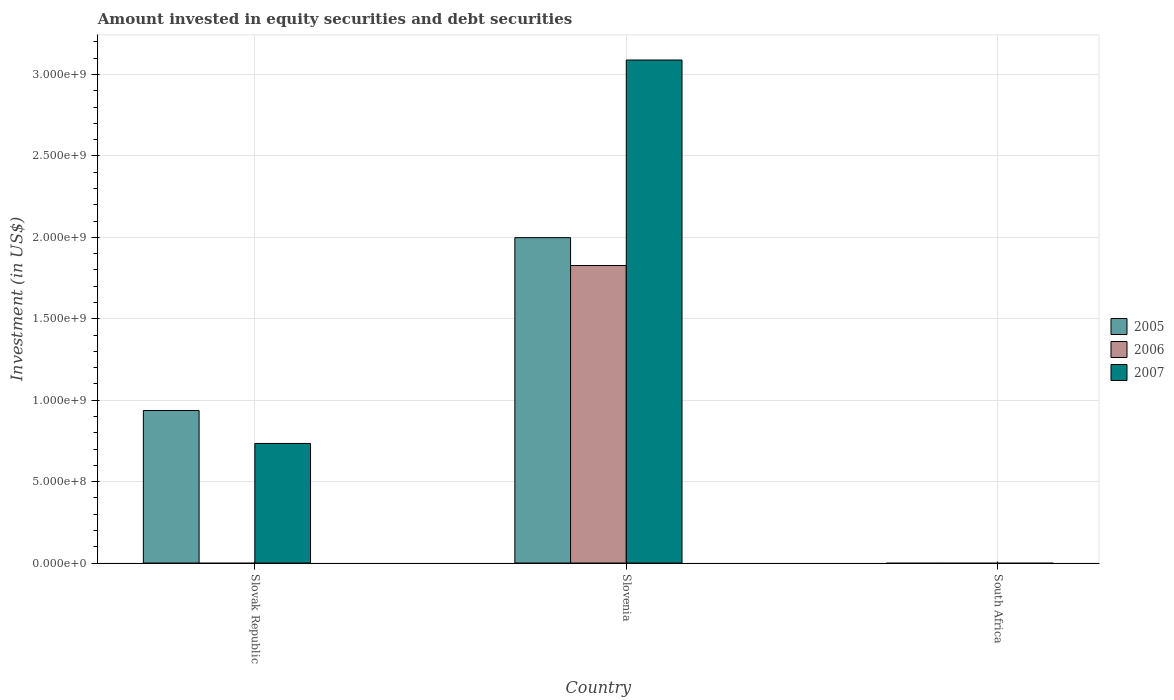Are the number of bars per tick equal to the number of legend labels?
Make the answer very short. No. Are the number of bars on each tick of the X-axis equal?
Your answer should be compact. No. How many bars are there on the 1st tick from the right?
Keep it short and to the point. 0. What is the label of the 3rd group of bars from the left?
Provide a short and direct response. South Africa. What is the amount invested in equity securities and debt securities in 2006 in Slovak Republic?
Your response must be concise. 0. Across all countries, what is the maximum amount invested in equity securities and debt securities in 2006?
Ensure brevity in your answer.  1.83e+09. In which country was the amount invested in equity securities and debt securities in 2007 maximum?
Ensure brevity in your answer.  Slovenia. What is the total amount invested in equity securities and debt securities in 2007 in the graph?
Offer a terse response. 3.82e+09. What is the difference between the amount invested in equity securities and debt securities in 2007 in Slovak Republic and that in Slovenia?
Ensure brevity in your answer.  -2.35e+09. What is the difference between the amount invested in equity securities and debt securities in 2005 in Slovak Republic and the amount invested in equity securities and debt securities in 2007 in Slovenia?
Your answer should be compact. -2.15e+09. What is the average amount invested in equity securities and debt securities in 2006 per country?
Ensure brevity in your answer.  6.09e+08. What is the difference between the amount invested in equity securities and debt securities of/in 2007 and amount invested in equity securities and debt securities of/in 2006 in Slovenia?
Offer a very short reply. 1.26e+09. What is the ratio of the amount invested in equity securities and debt securities in 2007 in Slovak Republic to that in Slovenia?
Offer a terse response. 0.24. Is the amount invested in equity securities and debt securities in 2007 in Slovak Republic less than that in Slovenia?
Give a very brief answer. Yes. What is the difference between the highest and the lowest amount invested in equity securities and debt securities in 2005?
Keep it short and to the point. 2.00e+09. In how many countries, is the amount invested in equity securities and debt securities in 2005 greater than the average amount invested in equity securities and debt securities in 2005 taken over all countries?
Offer a very short reply. 1. Is the sum of the amount invested in equity securities and debt securities in 2007 in Slovak Republic and Slovenia greater than the maximum amount invested in equity securities and debt securities in 2006 across all countries?
Provide a short and direct response. Yes. How many bars are there?
Ensure brevity in your answer.  5. Are all the bars in the graph horizontal?
Provide a succinct answer. No. How many countries are there in the graph?
Keep it short and to the point. 3. Are the values on the major ticks of Y-axis written in scientific E-notation?
Provide a short and direct response. Yes. Does the graph contain any zero values?
Offer a very short reply. Yes. Does the graph contain grids?
Keep it short and to the point. Yes. What is the title of the graph?
Offer a very short reply. Amount invested in equity securities and debt securities. What is the label or title of the X-axis?
Your answer should be compact. Country. What is the label or title of the Y-axis?
Provide a succinct answer. Investment (in US$). What is the Investment (in US$) of 2005 in Slovak Republic?
Your response must be concise. 9.37e+08. What is the Investment (in US$) of 2007 in Slovak Republic?
Make the answer very short. 7.34e+08. What is the Investment (in US$) of 2005 in Slovenia?
Ensure brevity in your answer.  2.00e+09. What is the Investment (in US$) of 2006 in Slovenia?
Provide a succinct answer. 1.83e+09. What is the Investment (in US$) in 2007 in Slovenia?
Provide a short and direct response. 3.09e+09. What is the Investment (in US$) in 2005 in South Africa?
Your answer should be compact. 0. What is the Investment (in US$) in 2007 in South Africa?
Your answer should be compact. 0. Across all countries, what is the maximum Investment (in US$) in 2005?
Offer a terse response. 2.00e+09. Across all countries, what is the maximum Investment (in US$) of 2006?
Your response must be concise. 1.83e+09. Across all countries, what is the maximum Investment (in US$) of 2007?
Keep it short and to the point. 3.09e+09. Across all countries, what is the minimum Investment (in US$) of 2005?
Your response must be concise. 0. Across all countries, what is the minimum Investment (in US$) in 2006?
Your response must be concise. 0. Across all countries, what is the minimum Investment (in US$) in 2007?
Your answer should be compact. 0. What is the total Investment (in US$) of 2005 in the graph?
Offer a terse response. 2.93e+09. What is the total Investment (in US$) in 2006 in the graph?
Your answer should be compact. 1.83e+09. What is the total Investment (in US$) of 2007 in the graph?
Provide a succinct answer. 3.82e+09. What is the difference between the Investment (in US$) of 2005 in Slovak Republic and that in Slovenia?
Provide a short and direct response. -1.06e+09. What is the difference between the Investment (in US$) of 2007 in Slovak Republic and that in Slovenia?
Keep it short and to the point. -2.35e+09. What is the difference between the Investment (in US$) in 2005 in Slovak Republic and the Investment (in US$) in 2006 in Slovenia?
Provide a short and direct response. -8.90e+08. What is the difference between the Investment (in US$) of 2005 in Slovak Republic and the Investment (in US$) of 2007 in Slovenia?
Offer a terse response. -2.15e+09. What is the average Investment (in US$) of 2005 per country?
Provide a succinct answer. 9.78e+08. What is the average Investment (in US$) of 2006 per country?
Offer a very short reply. 6.09e+08. What is the average Investment (in US$) of 2007 per country?
Make the answer very short. 1.27e+09. What is the difference between the Investment (in US$) of 2005 and Investment (in US$) of 2007 in Slovak Republic?
Offer a very short reply. 2.02e+08. What is the difference between the Investment (in US$) of 2005 and Investment (in US$) of 2006 in Slovenia?
Offer a terse response. 1.71e+08. What is the difference between the Investment (in US$) in 2005 and Investment (in US$) in 2007 in Slovenia?
Ensure brevity in your answer.  -1.09e+09. What is the difference between the Investment (in US$) of 2006 and Investment (in US$) of 2007 in Slovenia?
Give a very brief answer. -1.26e+09. What is the ratio of the Investment (in US$) in 2005 in Slovak Republic to that in Slovenia?
Provide a short and direct response. 0.47. What is the ratio of the Investment (in US$) in 2007 in Slovak Republic to that in Slovenia?
Provide a succinct answer. 0.24. What is the difference between the highest and the lowest Investment (in US$) in 2005?
Ensure brevity in your answer.  2.00e+09. What is the difference between the highest and the lowest Investment (in US$) of 2006?
Keep it short and to the point. 1.83e+09. What is the difference between the highest and the lowest Investment (in US$) in 2007?
Offer a very short reply. 3.09e+09. 